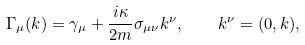<formula> <loc_0><loc_0><loc_500><loc_500>\Gamma _ { \mu } ( { k } ) = \gamma _ { \mu } + \frac { i \kappa } { 2 m } \sigma _ { \mu \nu } k ^ { \nu } , \quad k ^ { \nu } = ( 0 , { k } ) ,</formula> 